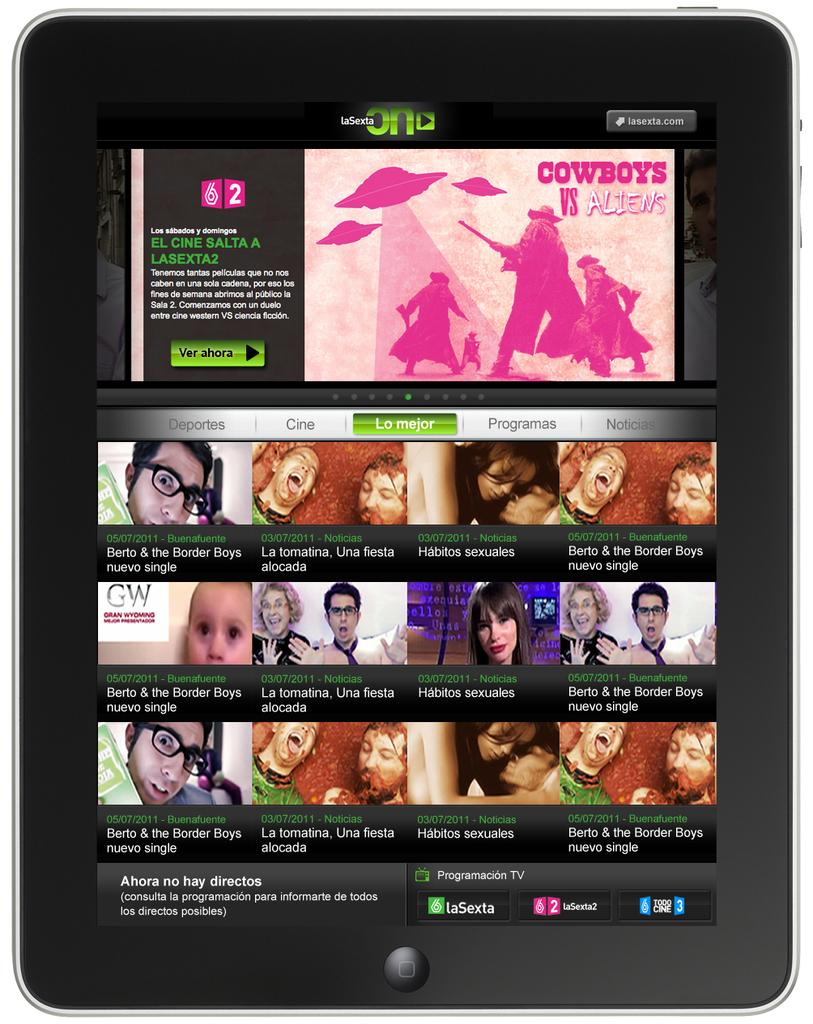What type of electronic device is present in the image? There is an electronic device in the image, but the specific type is not mentioned. What can be seen on the electronic device's display? The electronic device displays text. Are there any people visible on the electronic device? Yes, there are persons visible in the electronic device. What kind of animation is present on the electronic device? There is an animation of people in the electronic device. What type of butter is stored in the jar on the electronic device? There is no jar or butter present in the image; the electronic device displays text and an animation of people. 